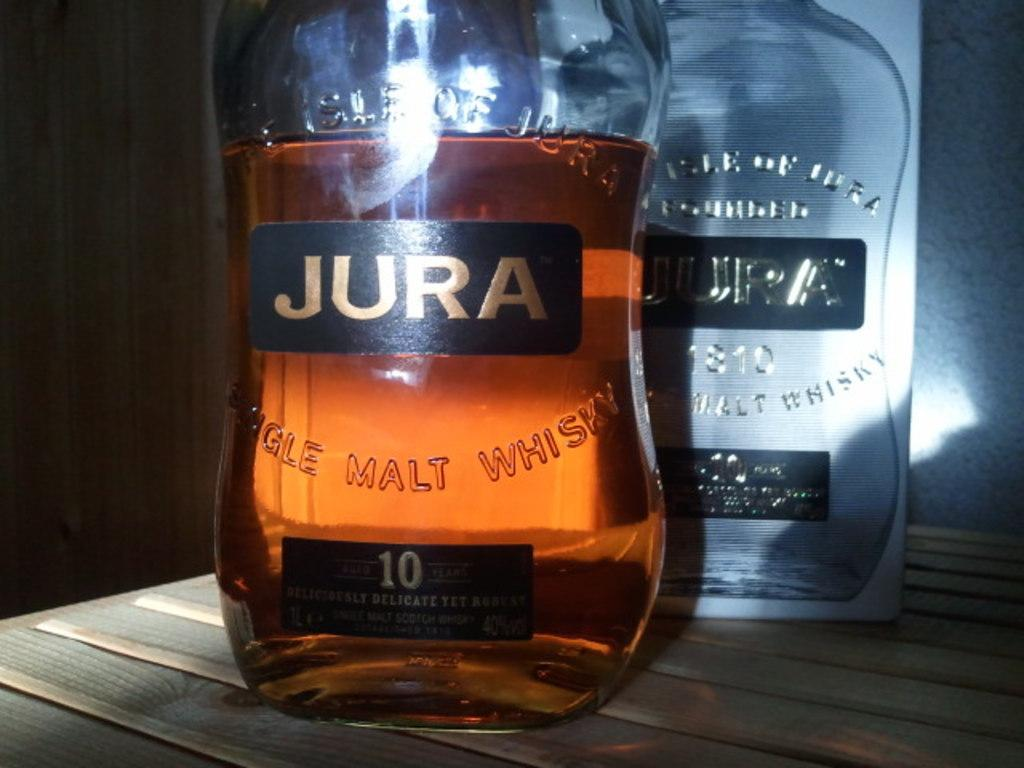<image>
Summarize the visual content of the image. A partially full bottle of Jura whisky in front of an empty one. 